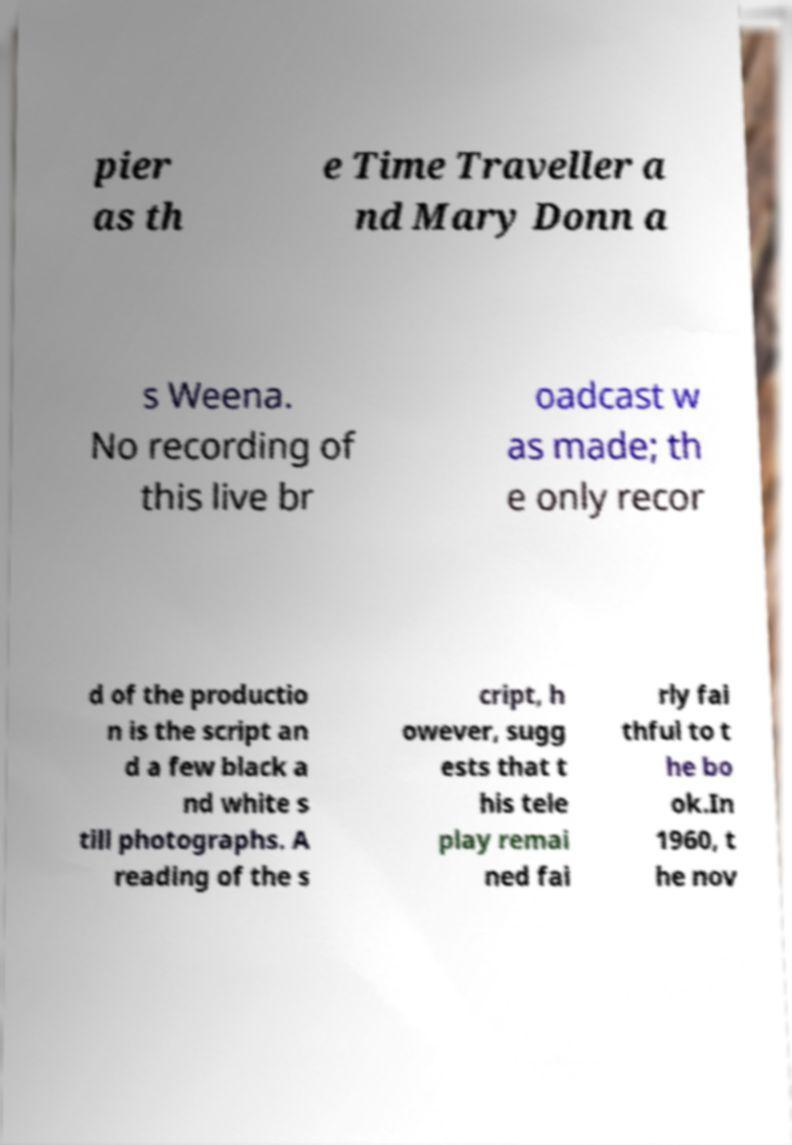Can you read and provide the text displayed in the image?This photo seems to have some interesting text. Can you extract and type it out for me? pier as th e Time Traveller a nd Mary Donn a s Weena. No recording of this live br oadcast w as made; th e only recor d of the productio n is the script an d a few black a nd white s till photographs. A reading of the s cript, h owever, sugg ests that t his tele play remai ned fai rly fai thful to t he bo ok.In 1960, t he nov 